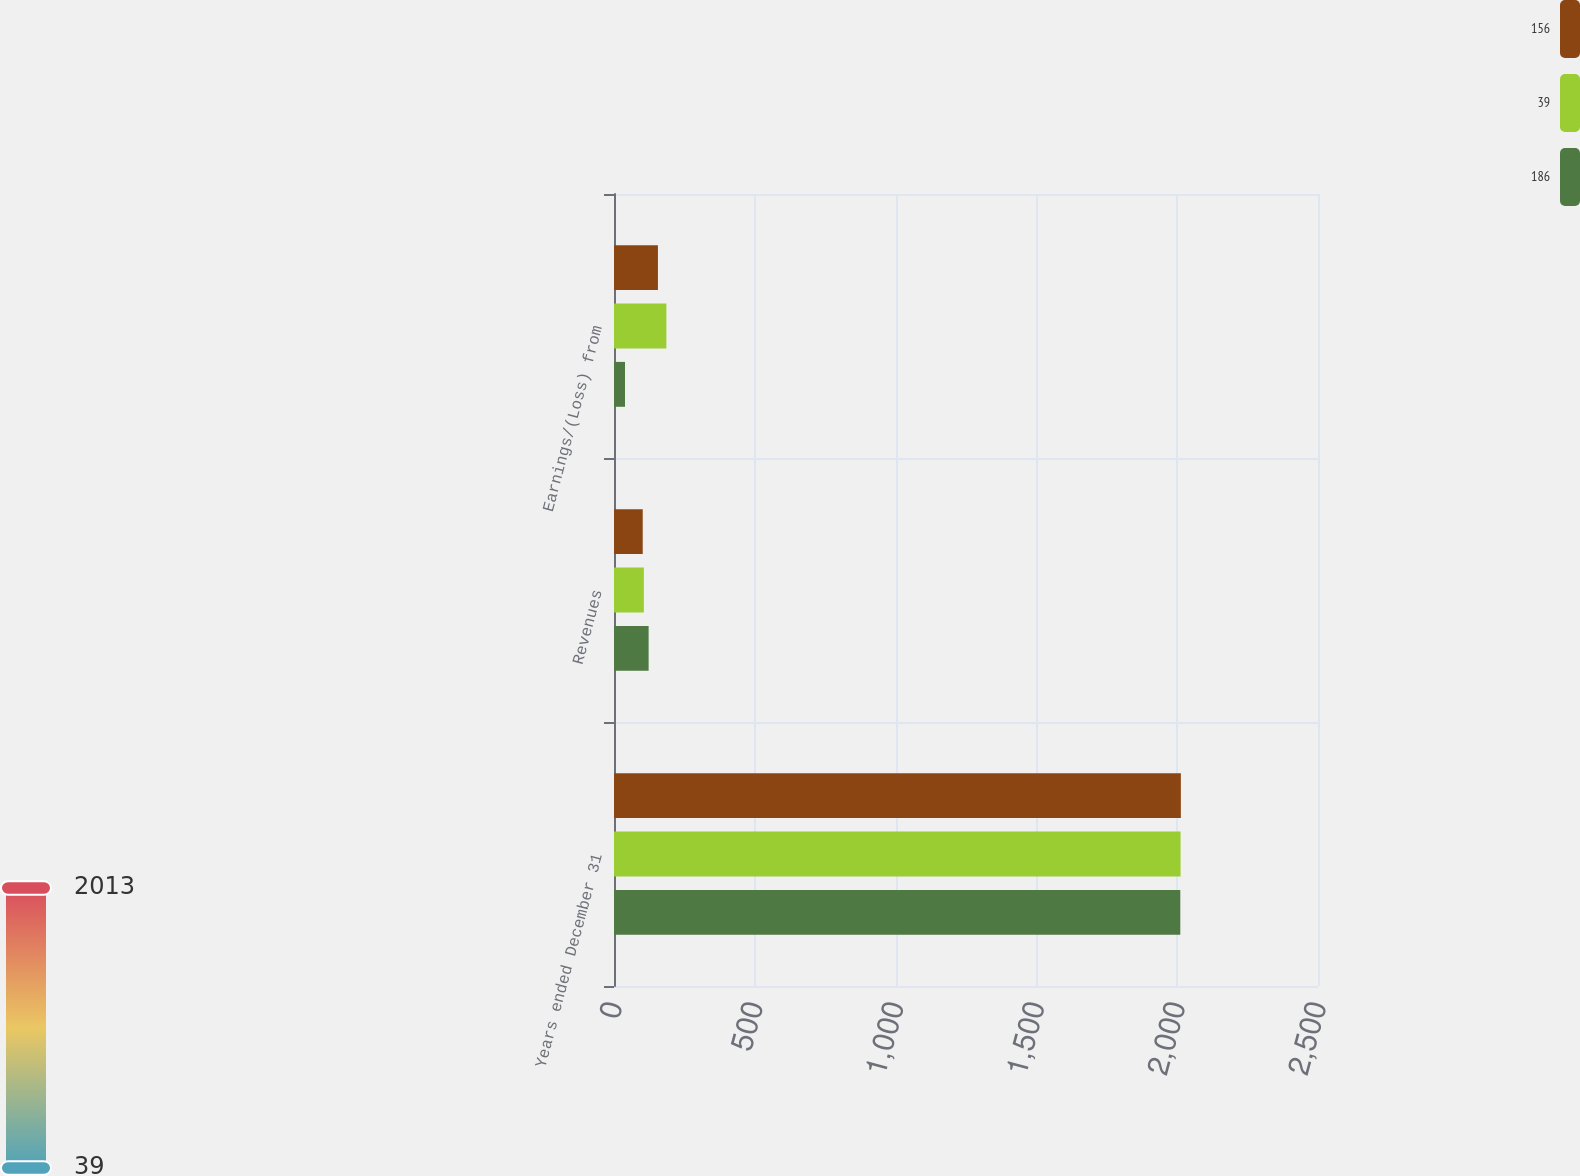Convert chart. <chart><loc_0><loc_0><loc_500><loc_500><stacked_bar_chart><ecel><fcel>Years ended December 31<fcel>Revenues<fcel>Earnings/(Loss) from<nl><fcel>156<fcel>2013<fcel>102<fcel>156<nl><fcel>39<fcel>2012<fcel>106<fcel>186<nl><fcel>186<fcel>2011<fcel>123<fcel>39<nl></chart> 